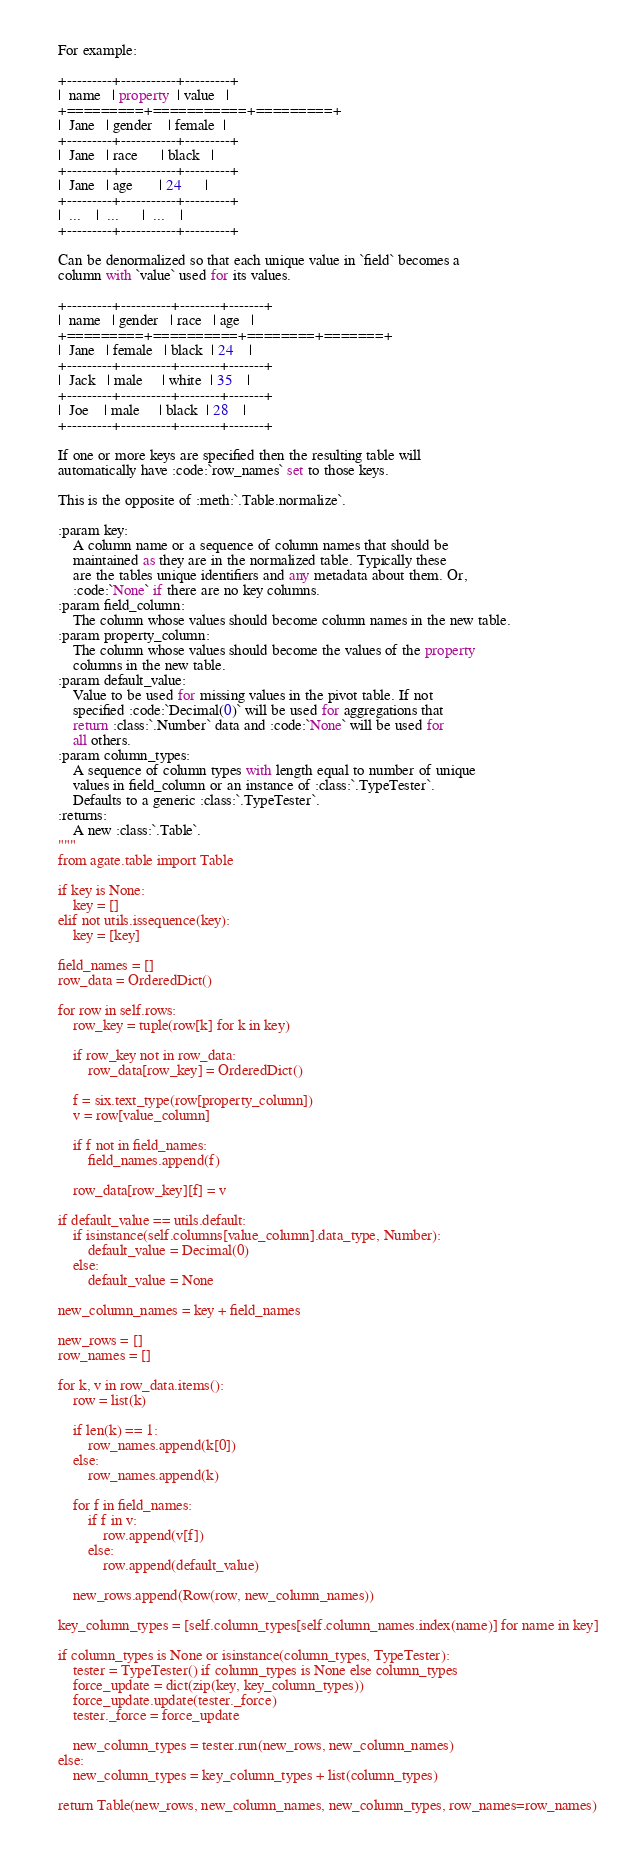Convert code to text. <code><loc_0><loc_0><loc_500><loc_500><_Python_>
    For example:

    +---------+-----------+---------+
    |  name   | property  | value   |
    +=========+===========+=========+
    |  Jane   | gender    | female  |
    +---------+-----------+---------+
    |  Jane   | race      | black   |
    +---------+-----------+---------+
    |  Jane   | age       | 24      |
    +---------+-----------+---------+
    |  ...    |  ...      |  ...    |
    +---------+-----------+---------+

    Can be denormalized so that each unique value in `field` becomes a
    column with `value` used for its values.

    +---------+----------+--------+-------+
    |  name   | gender   | race   | age   |
    +=========+==========+========+=======+
    |  Jane   | female   | black  | 24    |
    +---------+----------+--------+-------+
    |  Jack   | male     | white  | 35    |
    +---------+----------+--------+-------+
    |  Joe    | male     | black  | 28    |
    +---------+----------+--------+-------+

    If one or more keys are specified then the resulting table will
    automatically have :code:`row_names` set to those keys.

    This is the opposite of :meth:`.Table.normalize`.

    :param key:
        A column name or a sequence of column names that should be
        maintained as they are in the normalized table. Typically these
        are the tables unique identifiers and any metadata about them. Or,
        :code:`None` if there are no key columns.
    :param field_column:
        The column whose values should become column names in the new table.
    :param property_column:
        The column whose values should become the values of the property
        columns in the new table.
    :param default_value:
        Value to be used for missing values in the pivot table. If not
        specified :code:`Decimal(0)` will be used for aggregations that
        return :class:`.Number` data and :code:`None` will be used for
        all others.
    :param column_types:
        A sequence of column types with length equal to number of unique
        values in field_column or an instance of :class:`.TypeTester`.
        Defaults to a generic :class:`.TypeTester`.
    :returns:
        A new :class:`.Table`.
    """
    from agate.table import Table

    if key is None:
        key = []
    elif not utils.issequence(key):
        key = [key]

    field_names = []
    row_data = OrderedDict()

    for row in self.rows:
        row_key = tuple(row[k] for k in key)

        if row_key not in row_data:
            row_data[row_key] = OrderedDict()

        f = six.text_type(row[property_column])
        v = row[value_column]

        if f not in field_names:
            field_names.append(f)

        row_data[row_key][f] = v

    if default_value == utils.default:
        if isinstance(self.columns[value_column].data_type, Number):
            default_value = Decimal(0)
        else:
            default_value = None

    new_column_names = key + field_names

    new_rows = []
    row_names = []

    for k, v in row_data.items():
        row = list(k)

        if len(k) == 1:
            row_names.append(k[0])
        else:
            row_names.append(k)

        for f in field_names:
            if f in v:
                row.append(v[f])
            else:
                row.append(default_value)

        new_rows.append(Row(row, new_column_names))

    key_column_types = [self.column_types[self.column_names.index(name)] for name in key]

    if column_types is None or isinstance(column_types, TypeTester):
        tester = TypeTester() if column_types is None else column_types
        force_update = dict(zip(key, key_column_types))
        force_update.update(tester._force)
        tester._force = force_update

        new_column_types = tester.run(new_rows, new_column_names)
    else:
        new_column_types = key_column_types + list(column_types)

    return Table(new_rows, new_column_names, new_column_types, row_names=row_names)
</code> 